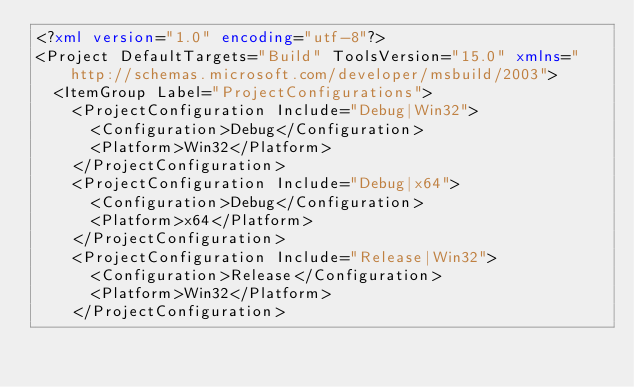Convert code to text. <code><loc_0><loc_0><loc_500><loc_500><_XML_><?xml version="1.0" encoding="utf-8"?>
<Project DefaultTargets="Build" ToolsVersion="15.0" xmlns="http://schemas.microsoft.com/developer/msbuild/2003">
  <ItemGroup Label="ProjectConfigurations">
    <ProjectConfiguration Include="Debug|Win32">
      <Configuration>Debug</Configuration>
      <Platform>Win32</Platform>
    </ProjectConfiguration>
    <ProjectConfiguration Include="Debug|x64">
      <Configuration>Debug</Configuration>
      <Platform>x64</Platform>
    </ProjectConfiguration>
    <ProjectConfiguration Include="Release|Win32">
      <Configuration>Release</Configuration>
      <Platform>Win32</Platform>
    </ProjectConfiguration></code> 